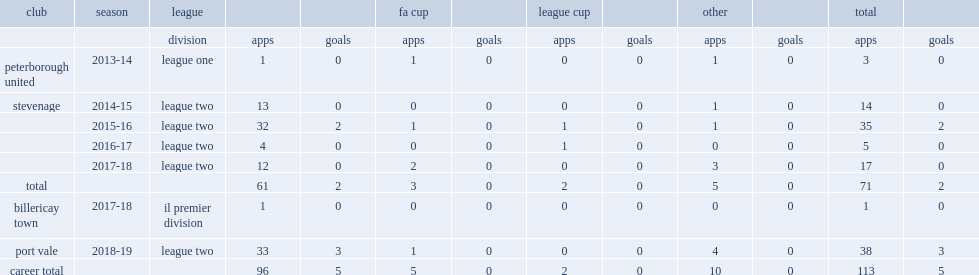How many appearances did the 2017-18 season conlon make as stevenage finished the league two? 17.0. 